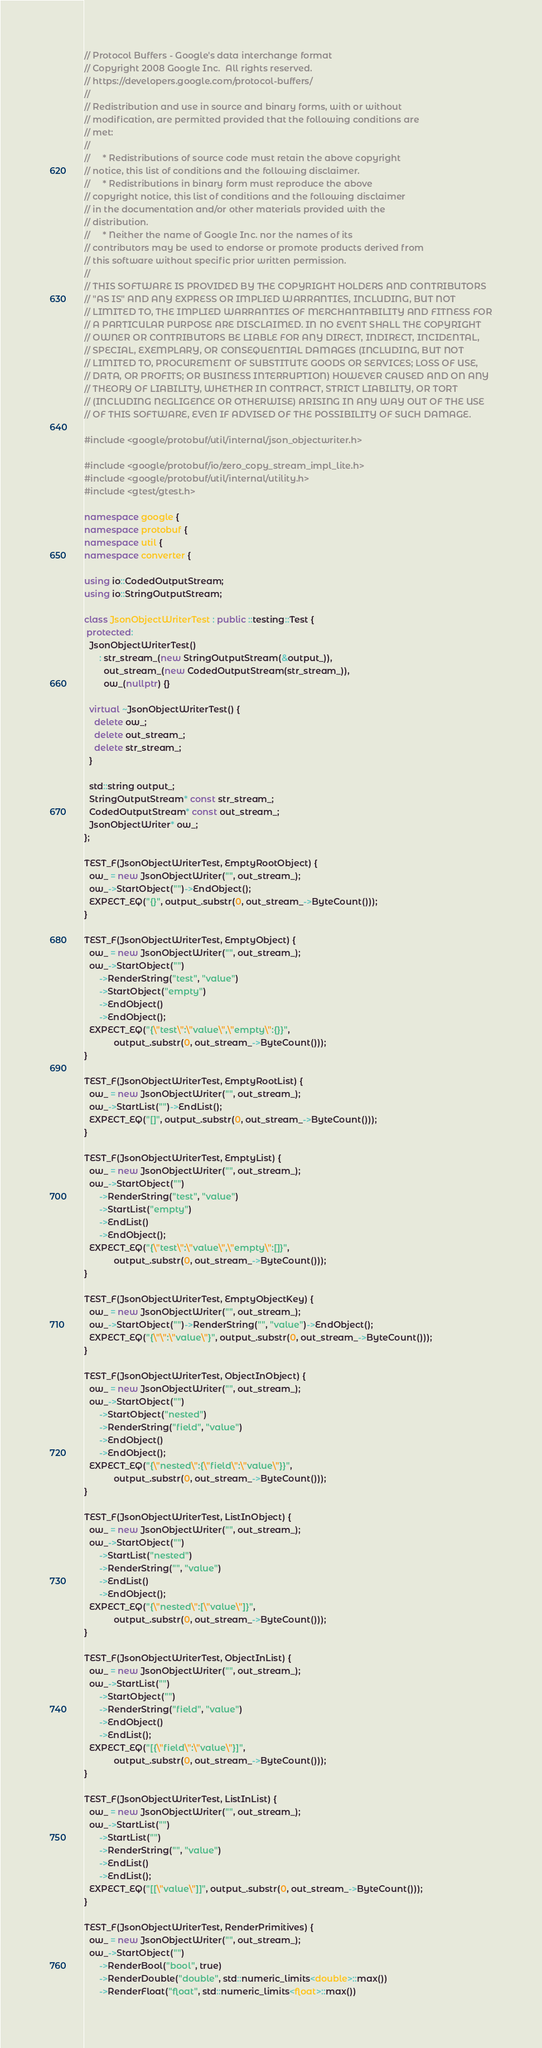Convert code to text. <code><loc_0><loc_0><loc_500><loc_500><_C++_>// Protocol Buffers - Google's data interchange format
// Copyright 2008 Google Inc.  All rights reserved.
// https://developers.google.com/protocol-buffers/
//
// Redistribution and use in source and binary forms, with or without
// modification, are permitted provided that the following conditions are
// met:
//
//     * Redistributions of source code must retain the above copyright
// notice, this list of conditions and the following disclaimer.
//     * Redistributions in binary form must reproduce the above
// copyright notice, this list of conditions and the following disclaimer
// in the documentation and/or other materials provided with the
// distribution.
//     * Neither the name of Google Inc. nor the names of its
// contributors may be used to endorse or promote products derived from
// this software without specific prior written permission.
//
// THIS SOFTWARE IS PROVIDED BY THE COPYRIGHT HOLDERS AND CONTRIBUTORS
// "AS IS" AND ANY EXPRESS OR IMPLIED WARRANTIES, INCLUDING, BUT NOT
// LIMITED TO, THE IMPLIED WARRANTIES OF MERCHANTABILITY AND FITNESS FOR
// A PARTICULAR PURPOSE ARE DISCLAIMED. IN NO EVENT SHALL THE COPYRIGHT
// OWNER OR CONTRIBUTORS BE LIABLE FOR ANY DIRECT, INDIRECT, INCIDENTAL,
// SPECIAL, EXEMPLARY, OR CONSEQUENTIAL DAMAGES (INCLUDING, BUT NOT
// LIMITED TO, PROCUREMENT OF SUBSTITUTE GOODS OR SERVICES; LOSS OF USE,
// DATA, OR PROFITS; OR BUSINESS INTERRUPTION) HOWEVER CAUSED AND ON ANY
// THEORY OF LIABILITY, WHETHER IN CONTRACT, STRICT LIABILITY, OR TORT
// (INCLUDING NEGLIGENCE OR OTHERWISE) ARISING IN ANY WAY OUT OF THE USE
// OF THIS SOFTWARE, EVEN IF ADVISED OF THE POSSIBILITY OF SUCH DAMAGE.

#include <google/protobuf/util/internal/json_objectwriter.h>

#include <google/protobuf/io/zero_copy_stream_impl_lite.h>
#include <google/protobuf/util/internal/utility.h>
#include <gtest/gtest.h>

namespace google {
namespace protobuf {
namespace util {
namespace converter {

using io::CodedOutputStream;
using io::StringOutputStream;

class JsonObjectWriterTest : public ::testing::Test {
 protected:
  JsonObjectWriterTest()
      : str_stream_(new StringOutputStream(&output_)),
        out_stream_(new CodedOutputStream(str_stream_)),
        ow_(nullptr) {}

  virtual ~JsonObjectWriterTest() {
    delete ow_;
    delete out_stream_;
    delete str_stream_;
  }

  std::string output_;
  StringOutputStream* const str_stream_;
  CodedOutputStream* const out_stream_;
  JsonObjectWriter* ow_;
};

TEST_F(JsonObjectWriterTest, EmptyRootObject) {
  ow_ = new JsonObjectWriter("", out_stream_);
  ow_->StartObject("")->EndObject();
  EXPECT_EQ("{}", output_.substr(0, out_stream_->ByteCount()));
}

TEST_F(JsonObjectWriterTest, EmptyObject) {
  ow_ = new JsonObjectWriter("", out_stream_);
  ow_->StartObject("")
      ->RenderString("test", "value")
      ->StartObject("empty")
      ->EndObject()
      ->EndObject();
  EXPECT_EQ("{\"test\":\"value\",\"empty\":{}}",
            output_.substr(0, out_stream_->ByteCount()));
}

TEST_F(JsonObjectWriterTest, EmptyRootList) {
  ow_ = new JsonObjectWriter("", out_stream_);
  ow_->StartList("")->EndList();
  EXPECT_EQ("[]", output_.substr(0, out_stream_->ByteCount()));
}

TEST_F(JsonObjectWriterTest, EmptyList) {
  ow_ = new JsonObjectWriter("", out_stream_);
  ow_->StartObject("")
      ->RenderString("test", "value")
      ->StartList("empty")
      ->EndList()
      ->EndObject();
  EXPECT_EQ("{\"test\":\"value\",\"empty\":[]}",
            output_.substr(0, out_stream_->ByteCount()));
}

TEST_F(JsonObjectWriterTest, EmptyObjectKey) {
  ow_ = new JsonObjectWriter("", out_stream_);
  ow_->StartObject("")->RenderString("", "value")->EndObject();
  EXPECT_EQ("{\"\":\"value\"}", output_.substr(0, out_stream_->ByteCount()));
}

TEST_F(JsonObjectWriterTest, ObjectInObject) {
  ow_ = new JsonObjectWriter("", out_stream_);
  ow_->StartObject("")
      ->StartObject("nested")
      ->RenderString("field", "value")
      ->EndObject()
      ->EndObject();
  EXPECT_EQ("{\"nested\":{\"field\":\"value\"}}",
            output_.substr(0, out_stream_->ByteCount()));
}

TEST_F(JsonObjectWriterTest, ListInObject) {
  ow_ = new JsonObjectWriter("", out_stream_);
  ow_->StartObject("")
      ->StartList("nested")
      ->RenderString("", "value")
      ->EndList()
      ->EndObject();
  EXPECT_EQ("{\"nested\":[\"value\"]}",
            output_.substr(0, out_stream_->ByteCount()));
}

TEST_F(JsonObjectWriterTest, ObjectInList) {
  ow_ = new JsonObjectWriter("", out_stream_);
  ow_->StartList("")
      ->StartObject("")
      ->RenderString("field", "value")
      ->EndObject()
      ->EndList();
  EXPECT_EQ("[{\"field\":\"value\"}]",
            output_.substr(0, out_stream_->ByteCount()));
}

TEST_F(JsonObjectWriterTest, ListInList) {
  ow_ = new JsonObjectWriter("", out_stream_);
  ow_->StartList("")
      ->StartList("")
      ->RenderString("", "value")
      ->EndList()
      ->EndList();
  EXPECT_EQ("[[\"value\"]]", output_.substr(0, out_stream_->ByteCount()));
}

TEST_F(JsonObjectWriterTest, RenderPrimitives) {
  ow_ = new JsonObjectWriter("", out_stream_);
  ow_->StartObject("")
      ->RenderBool("bool", true)
      ->RenderDouble("double", std::numeric_limits<double>::max())
      ->RenderFloat("float", std::numeric_limits<float>::max())</code> 